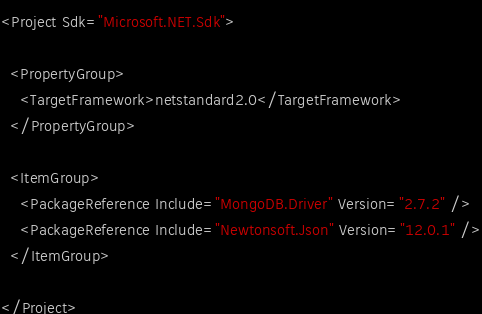<code> <loc_0><loc_0><loc_500><loc_500><_XML_><Project Sdk="Microsoft.NET.Sdk">

  <PropertyGroup>
    <TargetFramework>netstandard2.0</TargetFramework>
  </PropertyGroup>

  <ItemGroup>
    <PackageReference Include="MongoDB.Driver" Version="2.7.2" />
    <PackageReference Include="Newtonsoft.Json" Version="12.0.1" />
  </ItemGroup>

</Project>
</code> 